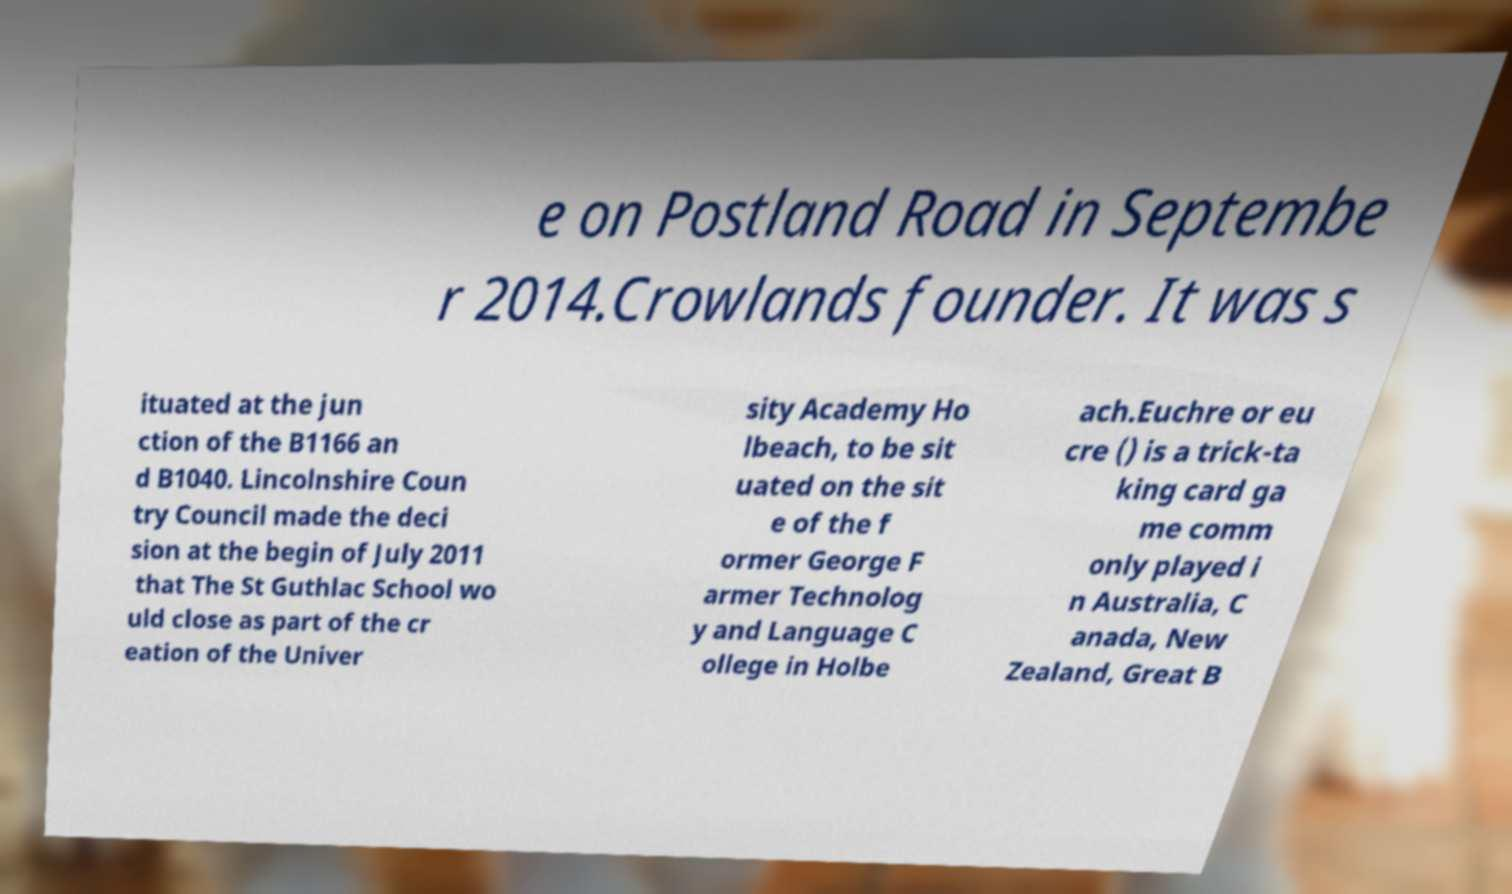Can you accurately transcribe the text from the provided image for me? e on Postland Road in Septembe r 2014.Crowlands founder. It was s ituated at the jun ction of the B1166 an d B1040. Lincolnshire Coun try Council made the deci sion at the begin of July 2011 that The St Guthlac School wo uld close as part of the cr eation of the Univer sity Academy Ho lbeach, to be sit uated on the sit e of the f ormer George F armer Technolog y and Language C ollege in Holbe ach.Euchre or eu cre () is a trick-ta king card ga me comm only played i n Australia, C anada, New Zealand, Great B 